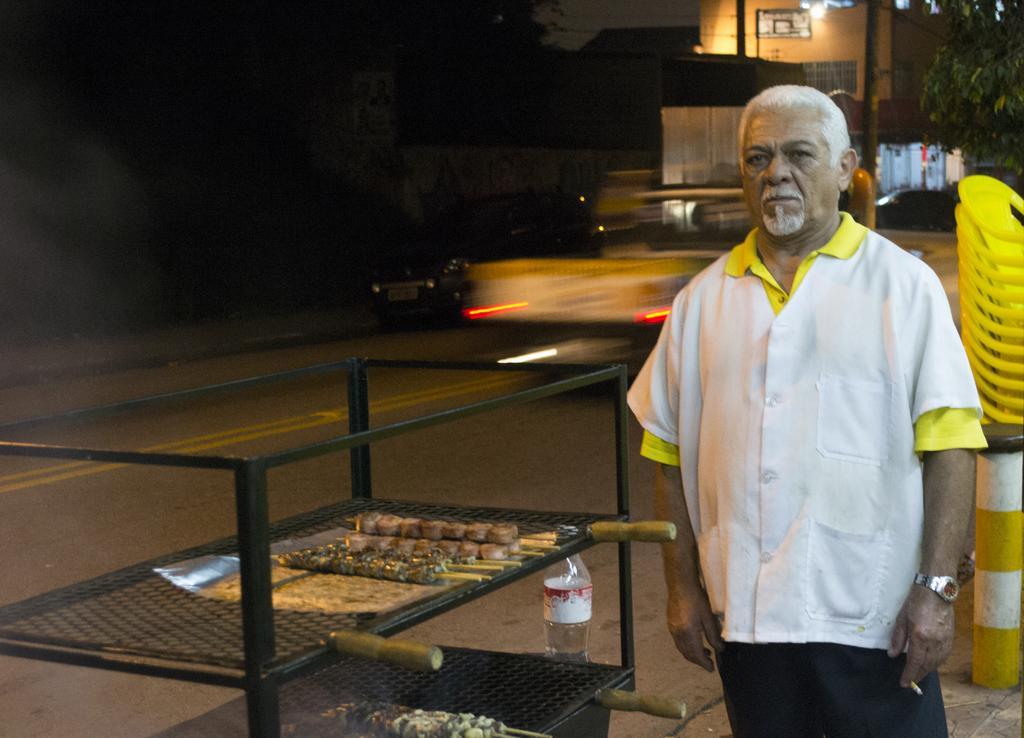Can you describe this image briefly? This image is taken outdoors. In this image the background is dark and there is a house. A vehicle is moving on the road and there is a tree. On the right side of the image there are a few chairs on the road. A man is standing on the road and he is holding a cigarette in his hand. On the left side of the image there is a road and there is an iron stand with two shelves. There are a few food items on the shelves and there is a bottle. 